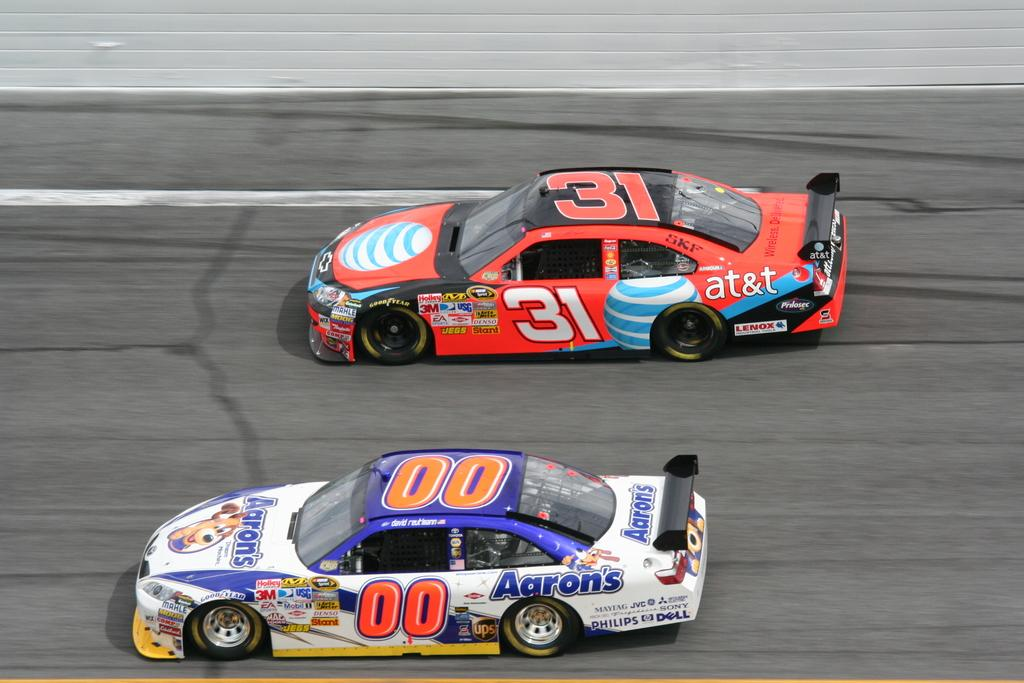How many cars can be seen in the image? There are two cars in the image. What are the cars doing in the image? The cars are riding on a road. Where is the prison located in the image? There is no prison present in the image; it only features two cars riding on a road. What type of partner is sitting in the car with the driver? There is no information about a partner or any passengers in the image, as it only shows two cars on a road. 